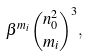<formula> <loc_0><loc_0><loc_500><loc_500>\beta ^ { m _ { i } } \binom { n _ { 0 } ^ { 2 } } { m _ { i } } ^ { 3 } ,</formula> 